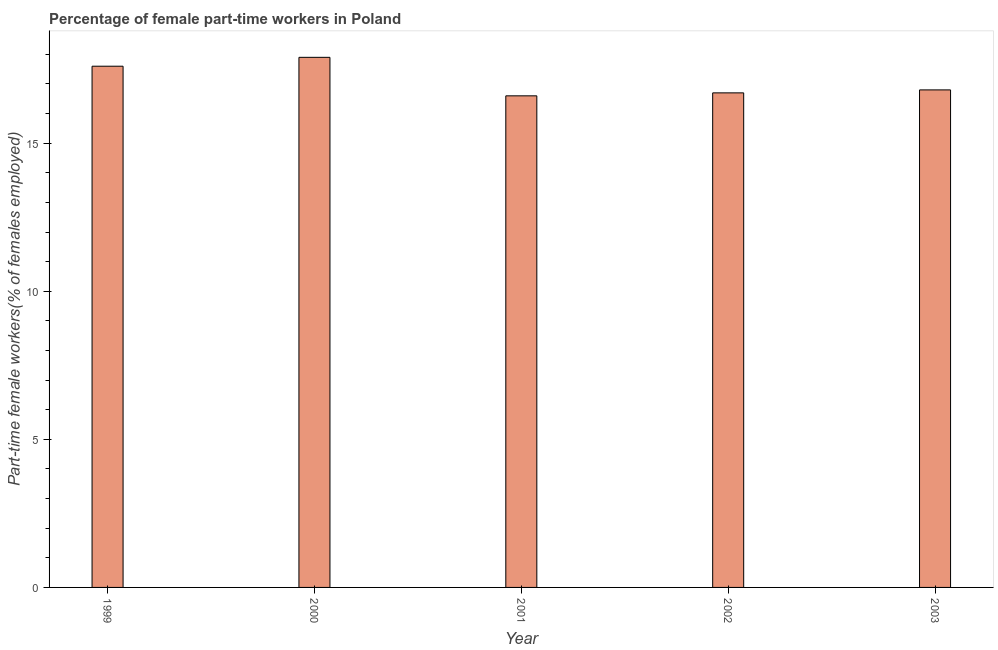What is the title of the graph?
Offer a very short reply. Percentage of female part-time workers in Poland. What is the label or title of the Y-axis?
Make the answer very short. Part-time female workers(% of females employed). What is the percentage of part-time female workers in 2000?
Give a very brief answer. 17.9. Across all years, what is the maximum percentage of part-time female workers?
Offer a very short reply. 17.9. Across all years, what is the minimum percentage of part-time female workers?
Offer a very short reply. 16.6. What is the sum of the percentage of part-time female workers?
Give a very brief answer. 85.6. What is the average percentage of part-time female workers per year?
Offer a very short reply. 17.12. What is the median percentage of part-time female workers?
Ensure brevity in your answer.  16.8. Do a majority of the years between 1999 and 2001 (inclusive) have percentage of part-time female workers greater than 12 %?
Your response must be concise. Yes. What is the ratio of the percentage of part-time female workers in 2000 to that in 2002?
Give a very brief answer. 1.07. What is the difference between the highest and the second highest percentage of part-time female workers?
Your answer should be very brief. 0.3. In how many years, is the percentage of part-time female workers greater than the average percentage of part-time female workers taken over all years?
Ensure brevity in your answer.  2. How many bars are there?
Offer a very short reply. 5. Are all the bars in the graph horizontal?
Offer a very short reply. No. How many years are there in the graph?
Keep it short and to the point. 5. What is the Part-time female workers(% of females employed) of 1999?
Give a very brief answer. 17.6. What is the Part-time female workers(% of females employed) in 2000?
Keep it short and to the point. 17.9. What is the Part-time female workers(% of females employed) in 2001?
Give a very brief answer. 16.6. What is the Part-time female workers(% of females employed) in 2002?
Give a very brief answer. 16.7. What is the Part-time female workers(% of females employed) of 2003?
Your answer should be very brief. 16.8. What is the difference between the Part-time female workers(% of females employed) in 1999 and 2000?
Offer a terse response. -0.3. What is the difference between the Part-time female workers(% of females employed) in 1999 and 2001?
Ensure brevity in your answer.  1. What is the difference between the Part-time female workers(% of females employed) in 2000 and 2002?
Keep it short and to the point. 1.2. What is the difference between the Part-time female workers(% of females employed) in 2000 and 2003?
Make the answer very short. 1.1. What is the ratio of the Part-time female workers(% of females employed) in 1999 to that in 2001?
Ensure brevity in your answer.  1.06. What is the ratio of the Part-time female workers(% of females employed) in 1999 to that in 2002?
Ensure brevity in your answer.  1.05. What is the ratio of the Part-time female workers(% of females employed) in 1999 to that in 2003?
Provide a succinct answer. 1.05. What is the ratio of the Part-time female workers(% of females employed) in 2000 to that in 2001?
Keep it short and to the point. 1.08. What is the ratio of the Part-time female workers(% of females employed) in 2000 to that in 2002?
Offer a terse response. 1.07. What is the ratio of the Part-time female workers(% of females employed) in 2000 to that in 2003?
Your response must be concise. 1.06. What is the ratio of the Part-time female workers(% of females employed) in 2002 to that in 2003?
Your answer should be very brief. 0.99. 